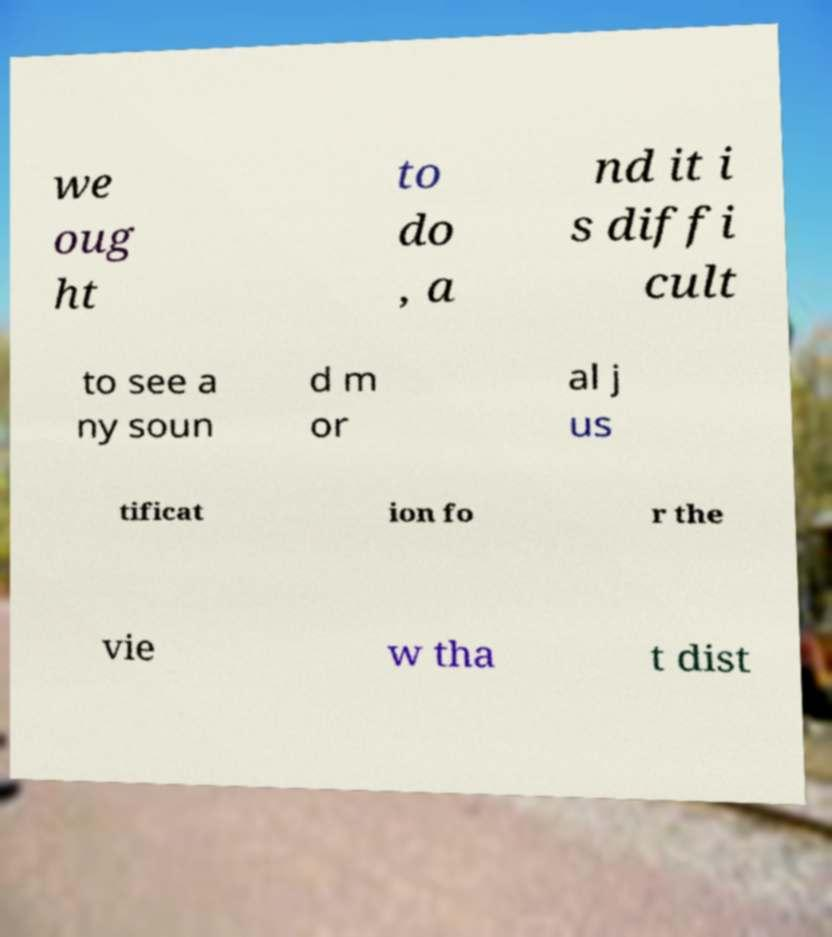Could you extract and type out the text from this image? we oug ht to do , a nd it i s diffi cult to see a ny soun d m or al j us tificat ion fo r the vie w tha t dist 